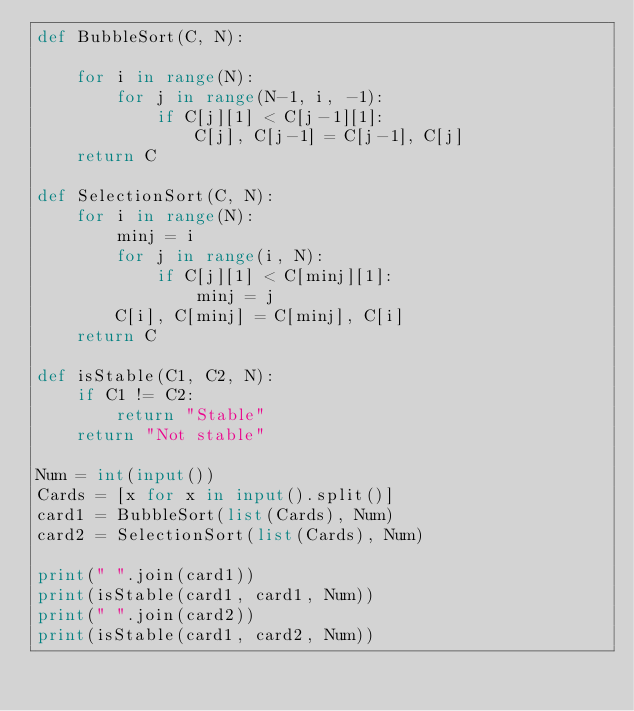<code> <loc_0><loc_0><loc_500><loc_500><_Python_>def BubbleSort(C, N):

    for i in range(N):
        for j in range(N-1, i, -1):
            if C[j][1] < C[j-1][1]:
                C[j], C[j-1] = C[j-1], C[j]
    return C

def SelectionSort(C, N):
    for i in range(N):
        minj = i
        for j in range(i, N):
            if C[j][1] < C[minj][1]:
                minj = j
        C[i], C[minj] = C[minj], C[i]
    return C

def isStable(C1, C2, N):
    if C1 != C2:
        return "Stable"
    return "Not stable"

Num = int(input())
Cards = [x for x in input().split()]
card1 = BubbleSort(list(Cards), Num)
card2 = SelectionSort(list(Cards), Num)

print(" ".join(card1))
print(isStable(card1, card1, Num))
print(" ".join(card2))
print(isStable(card1, card2, Num))

</code> 